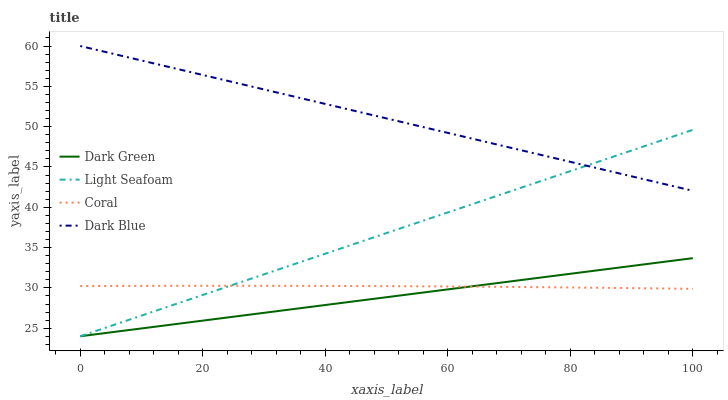Does Dark Green have the minimum area under the curve?
Answer yes or no. Yes. Does Dark Blue have the maximum area under the curve?
Answer yes or no. Yes. Does Coral have the minimum area under the curve?
Answer yes or no. No. Does Coral have the maximum area under the curve?
Answer yes or no. No. Is Dark Blue the smoothest?
Answer yes or no. Yes. Is Coral the roughest?
Answer yes or no. Yes. Is Light Seafoam the smoothest?
Answer yes or no. No. Is Light Seafoam the roughest?
Answer yes or no. No. Does Light Seafoam have the lowest value?
Answer yes or no. Yes. Does Coral have the lowest value?
Answer yes or no. No. Does Dark Blue have the highest value?
Answer yes or no. Yes. Does Light Seafoam have the highest value?
Answer yes or no. No. Is Coral less than Dark Blue?
Answer yes or no. Yes. Is Dark Blue greater than Dark Green?
Answer yes or no. Yes. Does Coral intersect Dark Green?
Answer yes or no. Yes. Is Coral less than Dark Green?
Answer yes or no. No. Is Coral greater than Dark Green?
Answer yes or no. No. Does Coral intersect Dark Blue?
Answer yes or no. No. 